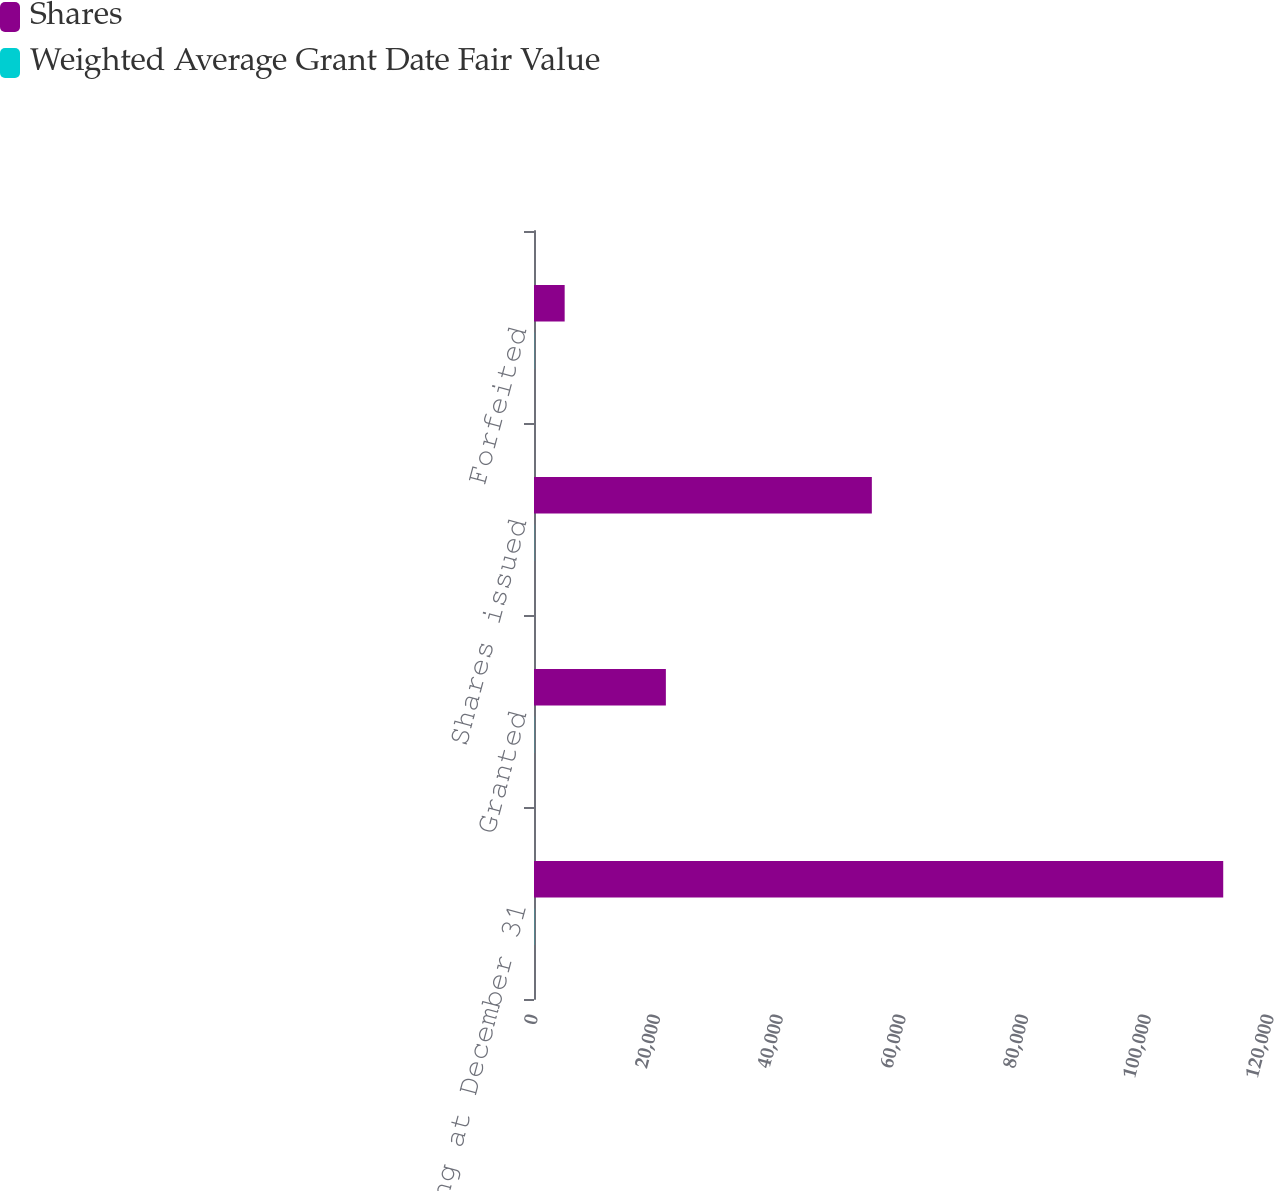Convert chart. <chart><loc_0><loc_0><loc_500><loc_500><stacked_bar_chart><ecel><fcel>Outstanding at December 31<fcel>Granted<fcel>Shares issued<fcel>Forfeited<nl><fcel>Shares<fcel>112374<fcel>21500<fcel>55083<fcel>5000<nl><fcel>Weighted Average Grant Date Fair Value<fcel>36.24<fcel>27.01<fcel>24.84<fcel>26.78<nl></chart> 